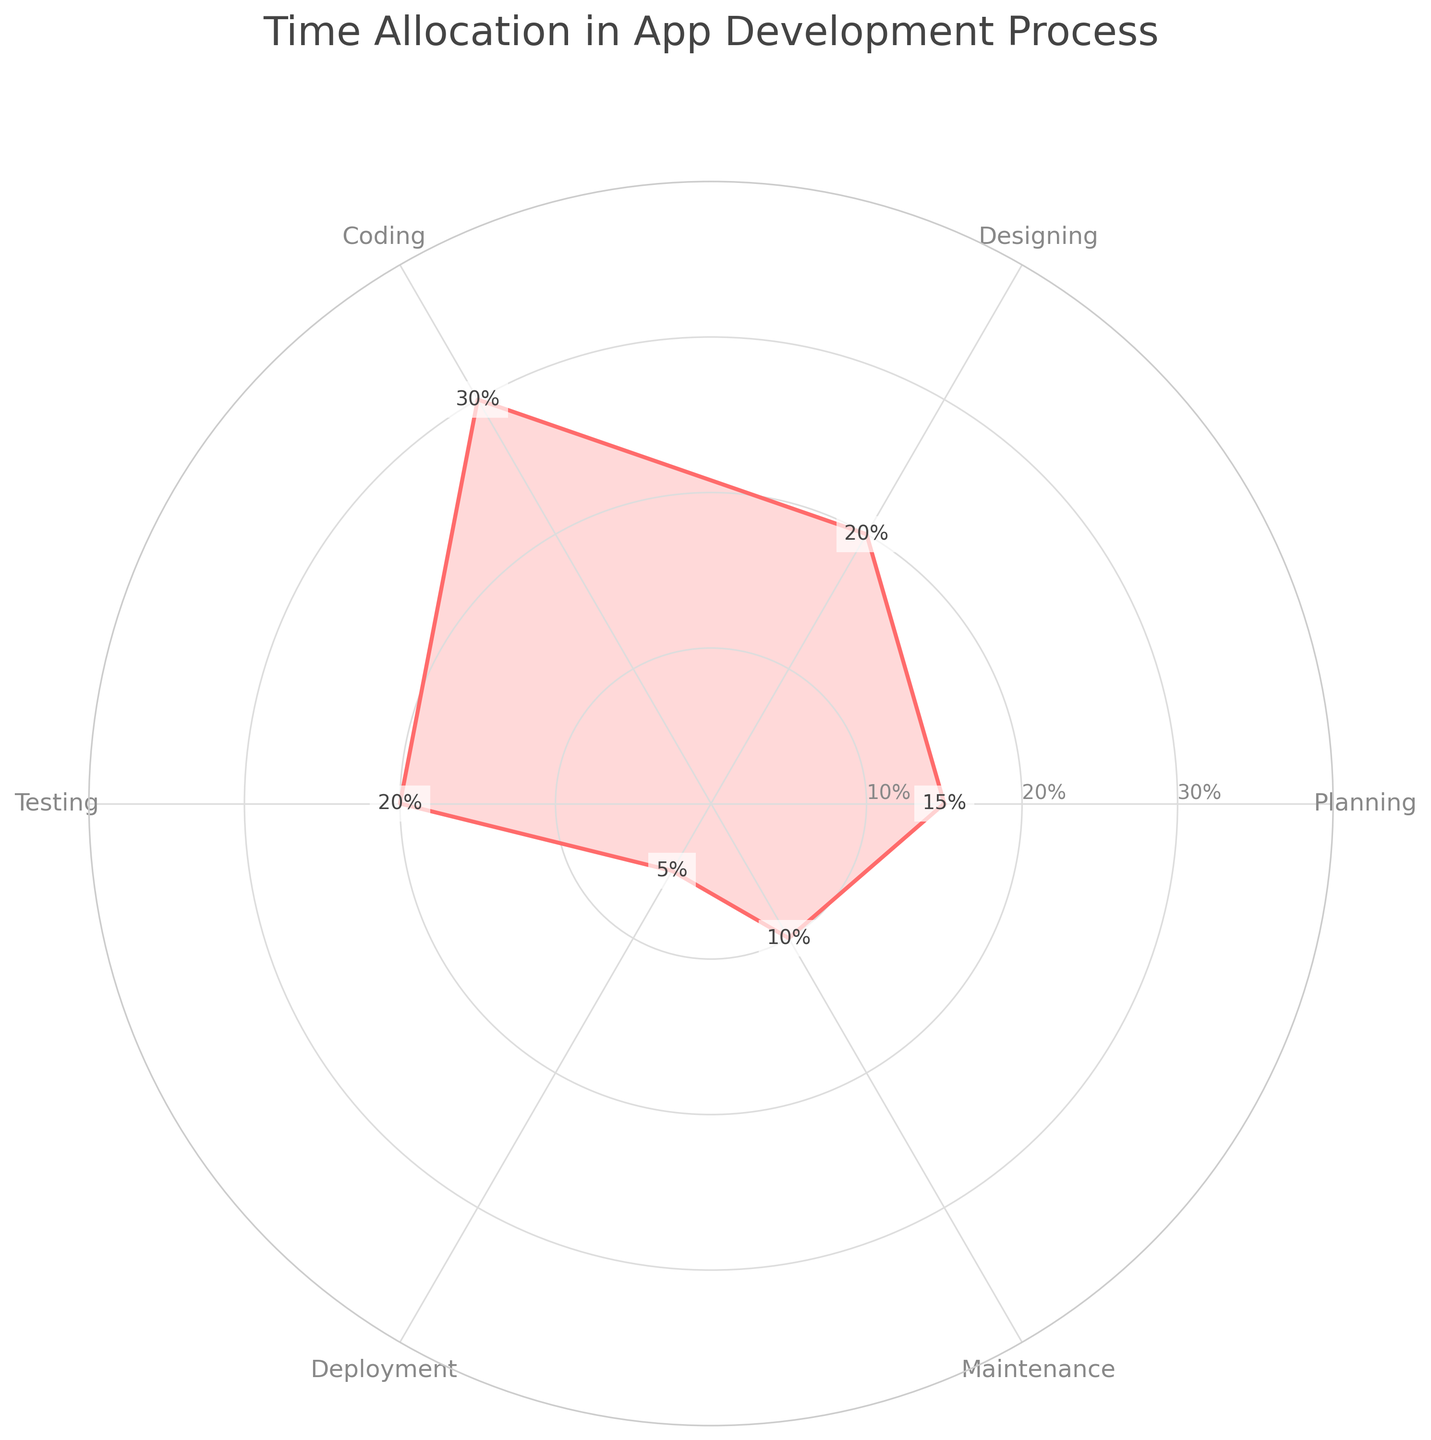What is the title of the radar chart? The title of the chart is the largest text usually located at the top of the figure. It provides a summary of what the chart represents. In this case, the title can be found centered above the radar chart.
Answer: Time Allocation in App Development Process Which phase receives the highest percentage of attention? Identify the phase by looking for the highest value on the radar chart. In this case, the highest value is 30%, which corresponds to the Coding phase.
Answer: Coding What are the five phases shown in the radar chart? By examining the labels along the outer edges of the radar chart, we can list all the phases. In this radar chart, there are six phases labeled.
Answer: Planning, Designing, Coding, Testing, Deployment, Maintenance What is the average percentage of time allocated to Testing and Maintenance? Add the percentages allocated to Testing and Maintenance, then divide by 2. Testing is 20% and Maintenance is 10%, so the average is (20% + 10%) / 2.
Answer: 15% How does the time allocated to Designing compare to that of Deployment? Find and compare the values of both Designing and Deployment phases on the radar chart. Designing is 20%, while Deployment is 5%.
Answer: Designing is greater than Deployment What is the combined percentage of time allocated to Planning and Deployment? Sum the percentages allocated to Planning and Deployment. Planning is 15%, and Deployment is 5%, so the sum is 15% + 5%.
Answer: 20% Which phase has the least amount of time allocated to it? Identify the phase with the smallest value on the radar chart. The phase with the smallest percentage is Deployment at 5%.
Answer: Deployment How many unique time allocation percentages are there, excluding replayed values? Count the unique percentages observed in the chart's data points. We have 15%, 20%, 30%, 20%, 5%, and 10%. Noting one repeated value of 20%, there are five unique values.
Answer: 5 Which two phases have equal percentages of time allocation? Identify phases with the same percentage values by examining the chart. Both Designing and Testing have equal amounts of 20%.
Answer: Designing and Testing What's the difference in percentage between the phase with the highest attention and the phase with the least attention? Subtract the smallest percentage value from the largest percentage value. The difference between 30% (Coding) and 5% (Deployment) is 30% - 5%.
Answer: 25% 